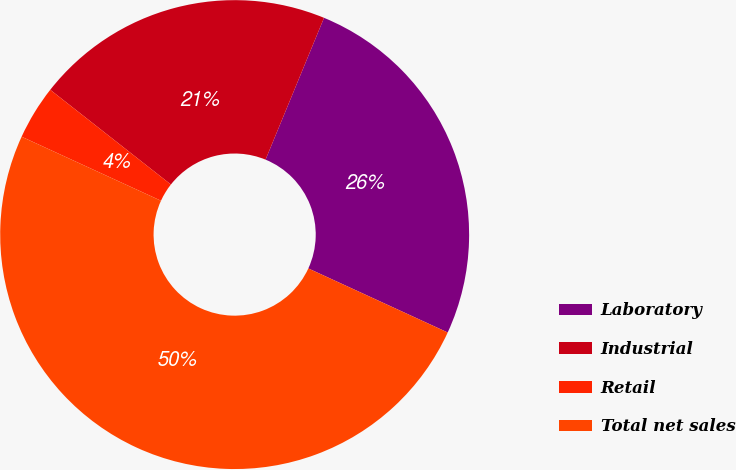Convert chart to OTSL. <chart><loc_0><loc_0><loc_500><loc_500><pie_chart><fcel>Laboratory<fcel>Industrial<fcel>Retail<fcel>Total net sales<nl><fcel>25.63%<fcel>20.63%<fcel>3.74%<fcel>50.0%<nl></chart> 